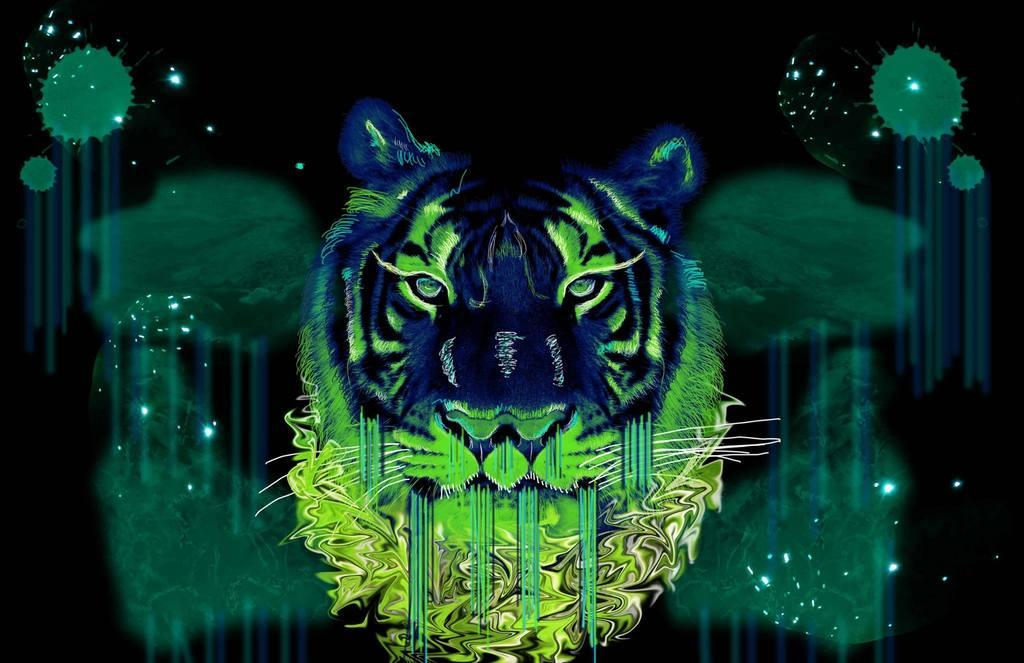What type of image is being described? The image is graphical. How many cars are parked in the yard in the image? There are no cars or yards present in the image, as it is a graphical image. 